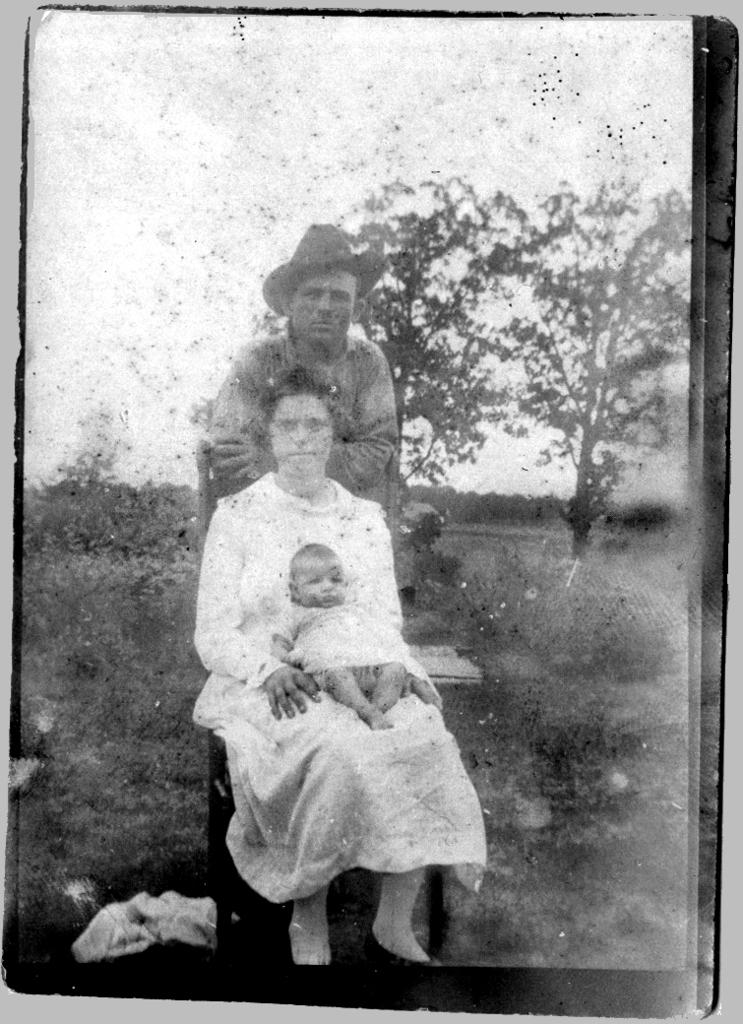What is the color scheme of the image? The image is black and white. Who can be seen in the picture? There is a baby and a woman in the picture. What is the woman doing in the image? The woman is sitting on a chair. Can you describe the background of the picture? There are trees and plants in the background of the picture. What type of bell can be heard ringing in the image? There is no bell present in the image, and therefore no sound can be heard. 